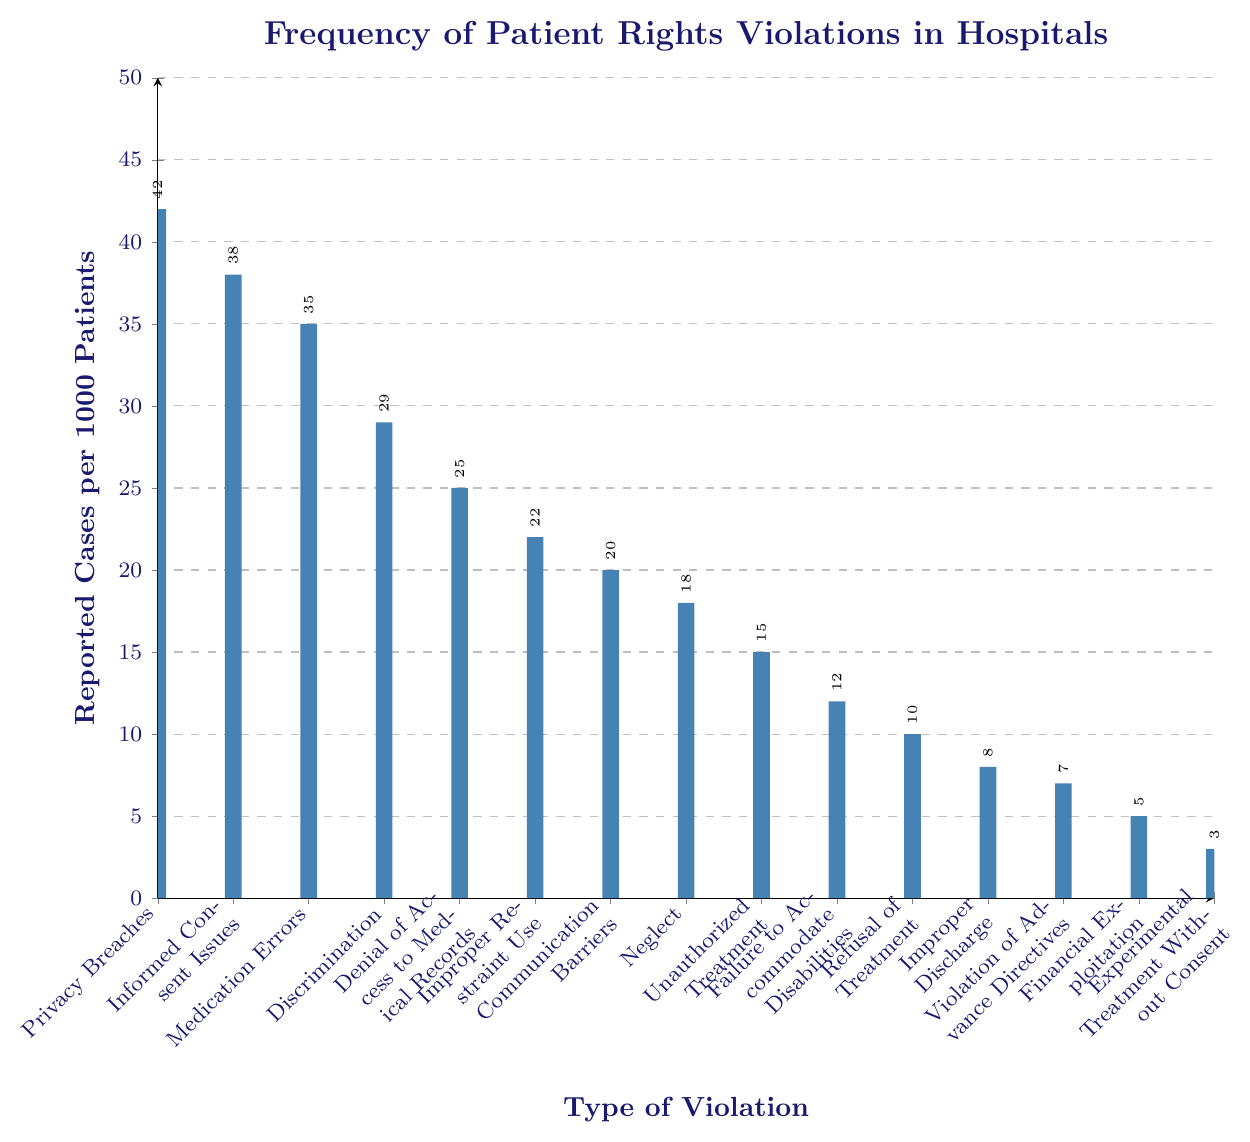Which type of violation has the highest number of reported cases? The bar for Privacy Breaches reaches the highest point on the y-axis compared to others, indicating it has the highest number of reported cases.
Answer: Privacy Breaches What is the difference in reported cases between Privacy Breaches and Unauthorized Treatment? The bar for Privacy Breaches shows 42 cases, and the bar for Unauthorized Treatment shows 15 cases. Subtract 15 from 42 to get the difference.
Answer: 27 Which violation type has the lowest frequency of reported cases? The Experimental Treatment Without Consent bar is the shortest among all bars, indicating the lowest number of reported cases.
Answer: Experimental Treatment Without Consent How many more reported cases are there for Discrimination than for Experimental Treatment Without Consent? The bar for Discrimination shows 29 cases, and the bar for Experimental Treatment Without Consent shows 3 cases. Subtract 3 from 29.
Answer: 26 What is the total number of reported cases for Communication Barriers and Neglect combined? The bar for Communication Barriers has 20 cases, and the bar for Neglect has 18 cases. Add these values together to get the total.
Answer: 38 Is the number of reported Medication Errors greater than or less than the number of Discrimination cases? The bar for Medication Errors shows 35 cases, and the bar for Discrimination shows 29 cases. 35 is greater than 29.
Answer: Greater Which two types of violations have reported cases in the range of 10 to 15 cases? The bars for Unauthorized Treatment and Refusal of Treatment both fall within the range of 10 to 15 cases.
Answer: Unauthorized Treatment and Refusal of Treatment What is the average number of reported cases among all types of violations? Add up the total number of reported cases for all violations and divide by the number of violation types (42 + 38 + 35 + 29 + 25 + 22 + 20 + 18 + 15 + 12 + 10 + 8 + 7 + 5 + 3). Divide by 15 (the number of violation types). (42 + 38 + 35 + 29 + 25 + 22 + 20 + 18 + 15 + 12 + 10 + 8 + 7 + 5 + 3 = 289), so 289 / 15 = 19.27
Answer: 19.27 Are the reported cases of Informed Consent Issues closer in number to Privacy Breaches or Medication Errors? The bar for Informed Consent Issues shows 38 cases, while Privacy Breaches have 42 cases and Medication Errors have 35 cases. The difference from Privacy Breaches is 4, whereas the difference from Medication Errors is 3, so it is closer to Medication Errors.
Answer: Medication Errors 